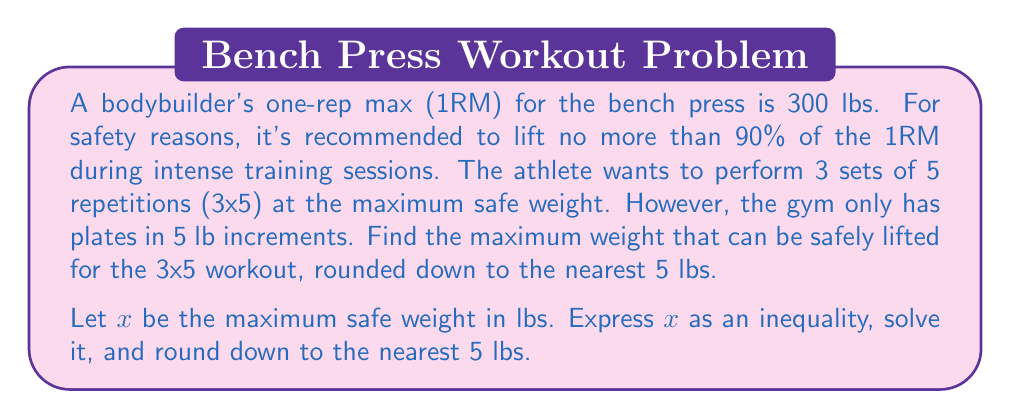Could you help me with this problem? Let's approach this step-by-step:

1) First, we need to express the maximum safe weight as a percentage of the 1RM:
   $x \leq 0.90 \times 300$

2) Simplify the right side of the inequality:
   $x \leq 270$

3) Since we need to round down to the nearest 5 lbs, we can express this as:
   $x \leq 270$ and $x$ is divisible by 5

4) The largest multiple of 5 that satisfies this inequality is 270 itself.

5) Therefore, the maximum weight that can be safely lifted, rounded down to the nearest 5 lbs, is 270 lbs.

This weight represents 90% of the bodybuilder's 1RM, which is the upper limit of the recommended safe range for intense training. It's also conveniently divisible by 5, making it easy to load the barbell with the available plates.
Answer: 270 lbs 